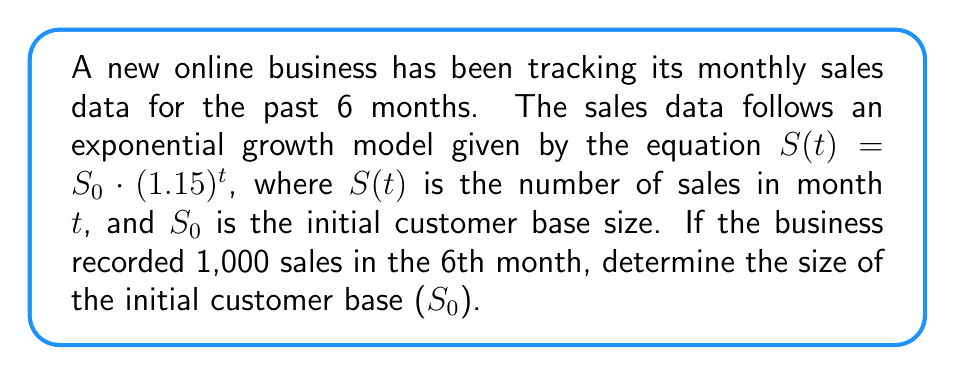Solve this math problem. To solve this inverse problem, we'll follow these steps:

1) We know that in the 6th month (t = 6), the number of sales was 1,000. Let's plug this into our equation:

   $1000 = S_0 \cdot (1.15)^6$

2) Now, we need to solve for $S_0$. First, let's calculate $(1.15)^6$:

   $(1.15)^6 \approx 2.3131$

3) Our equation now looks like this:

   $1000 = S_0 \cdot 2.3131$

4) To isolate $S_0$, we divide both sides by 2.3131:

   $S_0 = \frac{1000}{2.3131}$

5) Calculating this:

   $S_0 \approx 432.32$

6) Since we're dealing with a number of customers, we need to round to the nearest whole number:

   $S_0 = 432$

Therefore, the initial customer base size was approximately 432 customers.
Answer: 432 customers 